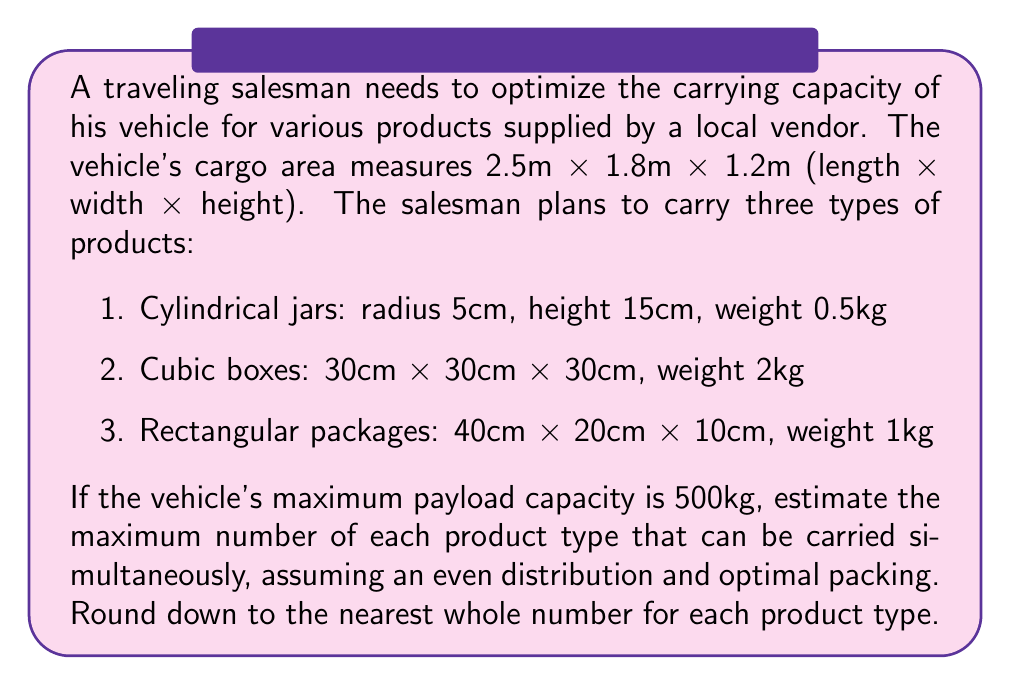Can you solve this math problem? To solve this problem, we'll follow these steps:

1. Calculate the volume of the cargo area
2. Calculate the volume of each product type
3. Estimate the number of each product that can fit in the cargo area
4. Calculate the total weight of the products
5. Adjust the quantities to meet the weight limit

Step 1: Calculate the cargo area volume
$$V_{cargo} = 2.5m \times 1.8m \times 1.2m = 5.4m^3 = 5,400,000cm^3$$

Step 2: Calculate product volumes
1. Cylindrical jars: $$V_{jar} = \pi r^2 h = \pi \times 5^2 \times 15 \approx 1,178cm^3$$
2. Cubic boxes: $$V_{box} = 30 \times 30 \times 30 = 27,000cm^3$$
3. Rectangular packages: $$V_{package} = 40 \times 20 \times 10 = 8,000cm^3$$

Step 3: Estimate the number of each product
Assuming optimal packing and even distribution:
$$n_{total} = \frac{V_{cargo}}{3(V_{jar} + V_{box} + V_{package})}$$
$$n_{total} = \frac{5,400,000}{3(1,178 + 27,000 + 8,000)} \approx 44.7$$

Rounding down, we get 44 of each product type.

Step 4: Calculate total weight
$$W_{total} = 44(0.5 + 2 + 1) = 44 \times 3.5 = 154kg$$

Step 5: Adjust quantities to meet weight limit
Since the total weight is well below the 500kg limit, we can increase the quantities. Let's multiply by 3:

$$W_{adjusted} = 3 \times 154kg = 462kg$$

This is still under the 500kg limit, so our final estimate is:
- Cylindrical jars: 132
- Cubic boxes: 132
- Rectangular packages: 132
Answer: 132 of each product type 